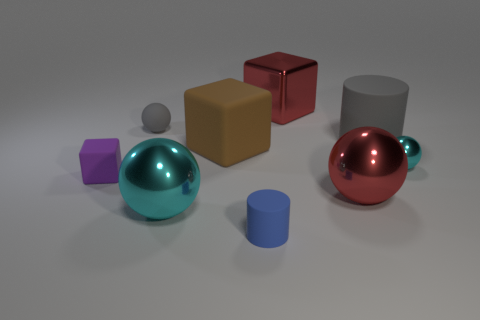There is a tiny purple object; what shape is it?
Provide a short and direct response. Cube. There is a metallic object that is the same color as the metallic cube; what size is it?
Your answer should be compact. Large. How many small matte objects have the same color as the big cylinder?
Offer a very short reply. 1. How many cyan balls have the same material as the red block?
Make the answer very short. 2. Is the size of the matte block that is left of the tiny gray matte object the same as the cyan metallic sphere on the right side of the large metallic cube?
Your response must be concise. Yes. What is the color of the large metallic ball on the right side of the cyan metal thing to the left of the large red metallic object right of the red block?
Offer a terse response. Red. Are there any big gray matte things of the same shape as the large cyan thing?
Give a very brief answer. No. Is the number of gray things that are in front of the big gray object the same as the number of big objects in front of the tiny blue rubber cylinder?
Offer a very short reply. Yes. There is a red metal object in front of the gray matte sphere; does it have the same shape as the big cyan object?
Your answer should be compact. Yes. Do the tiny cyan object and the tiny gray object have the same shape?
Your answer should be compact. Yes. 